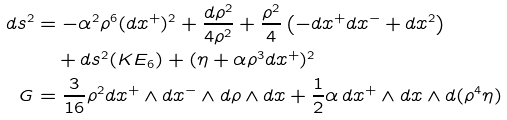Convert formula to latex. <formula><loc_0><loc_0><loc_500><loc_500>d s ^ { 2 } & = - \alpha ^ { 2 } \rho ^ { 6 } ( d x ^ { + } ) ^ { 2 } + \frac { d \rho ^ { 2 } } { 4 \rho ^ { 2 } } + \frac { \rho ^ { 2 } } { 4 } \left ( - d x ^ { + } d x ^ { - } + d x ^ { 2 } \right ) \\ & \quad + d s ^ { 2 } ( K E _ { 6 } ) + ( \eta + \alpha \rho ^ { 3 } d x ^ { + } ) ^ { 2 } \\ G & = \frac { 3 } { 1 6 } \rho ^ { 2 } d x ^ { + } \wedge d x ^ { - } \wedge d \rho \wedge d x + \frac { 1 } { 2 } \alpha \, d x ^ { + } \wedge d x \wedge d ( \rho ^ { 4 } \eta )</formula> 